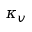<formula> <loc_0><loc_0><loc_500><loc_500>\kappa _ { v }</formula> 